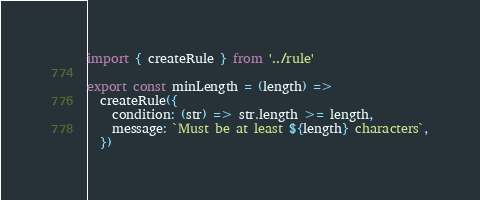<code> <loc_0><loc_0><loc_500><loc_500><_TypeScript_>import { createRule } from '../rule'

export const minLength = (length) =>
  createRule({
    condition: (str) => str.length >= length,
    message: `Must be at least ${length} characters`,
  })
</code> 